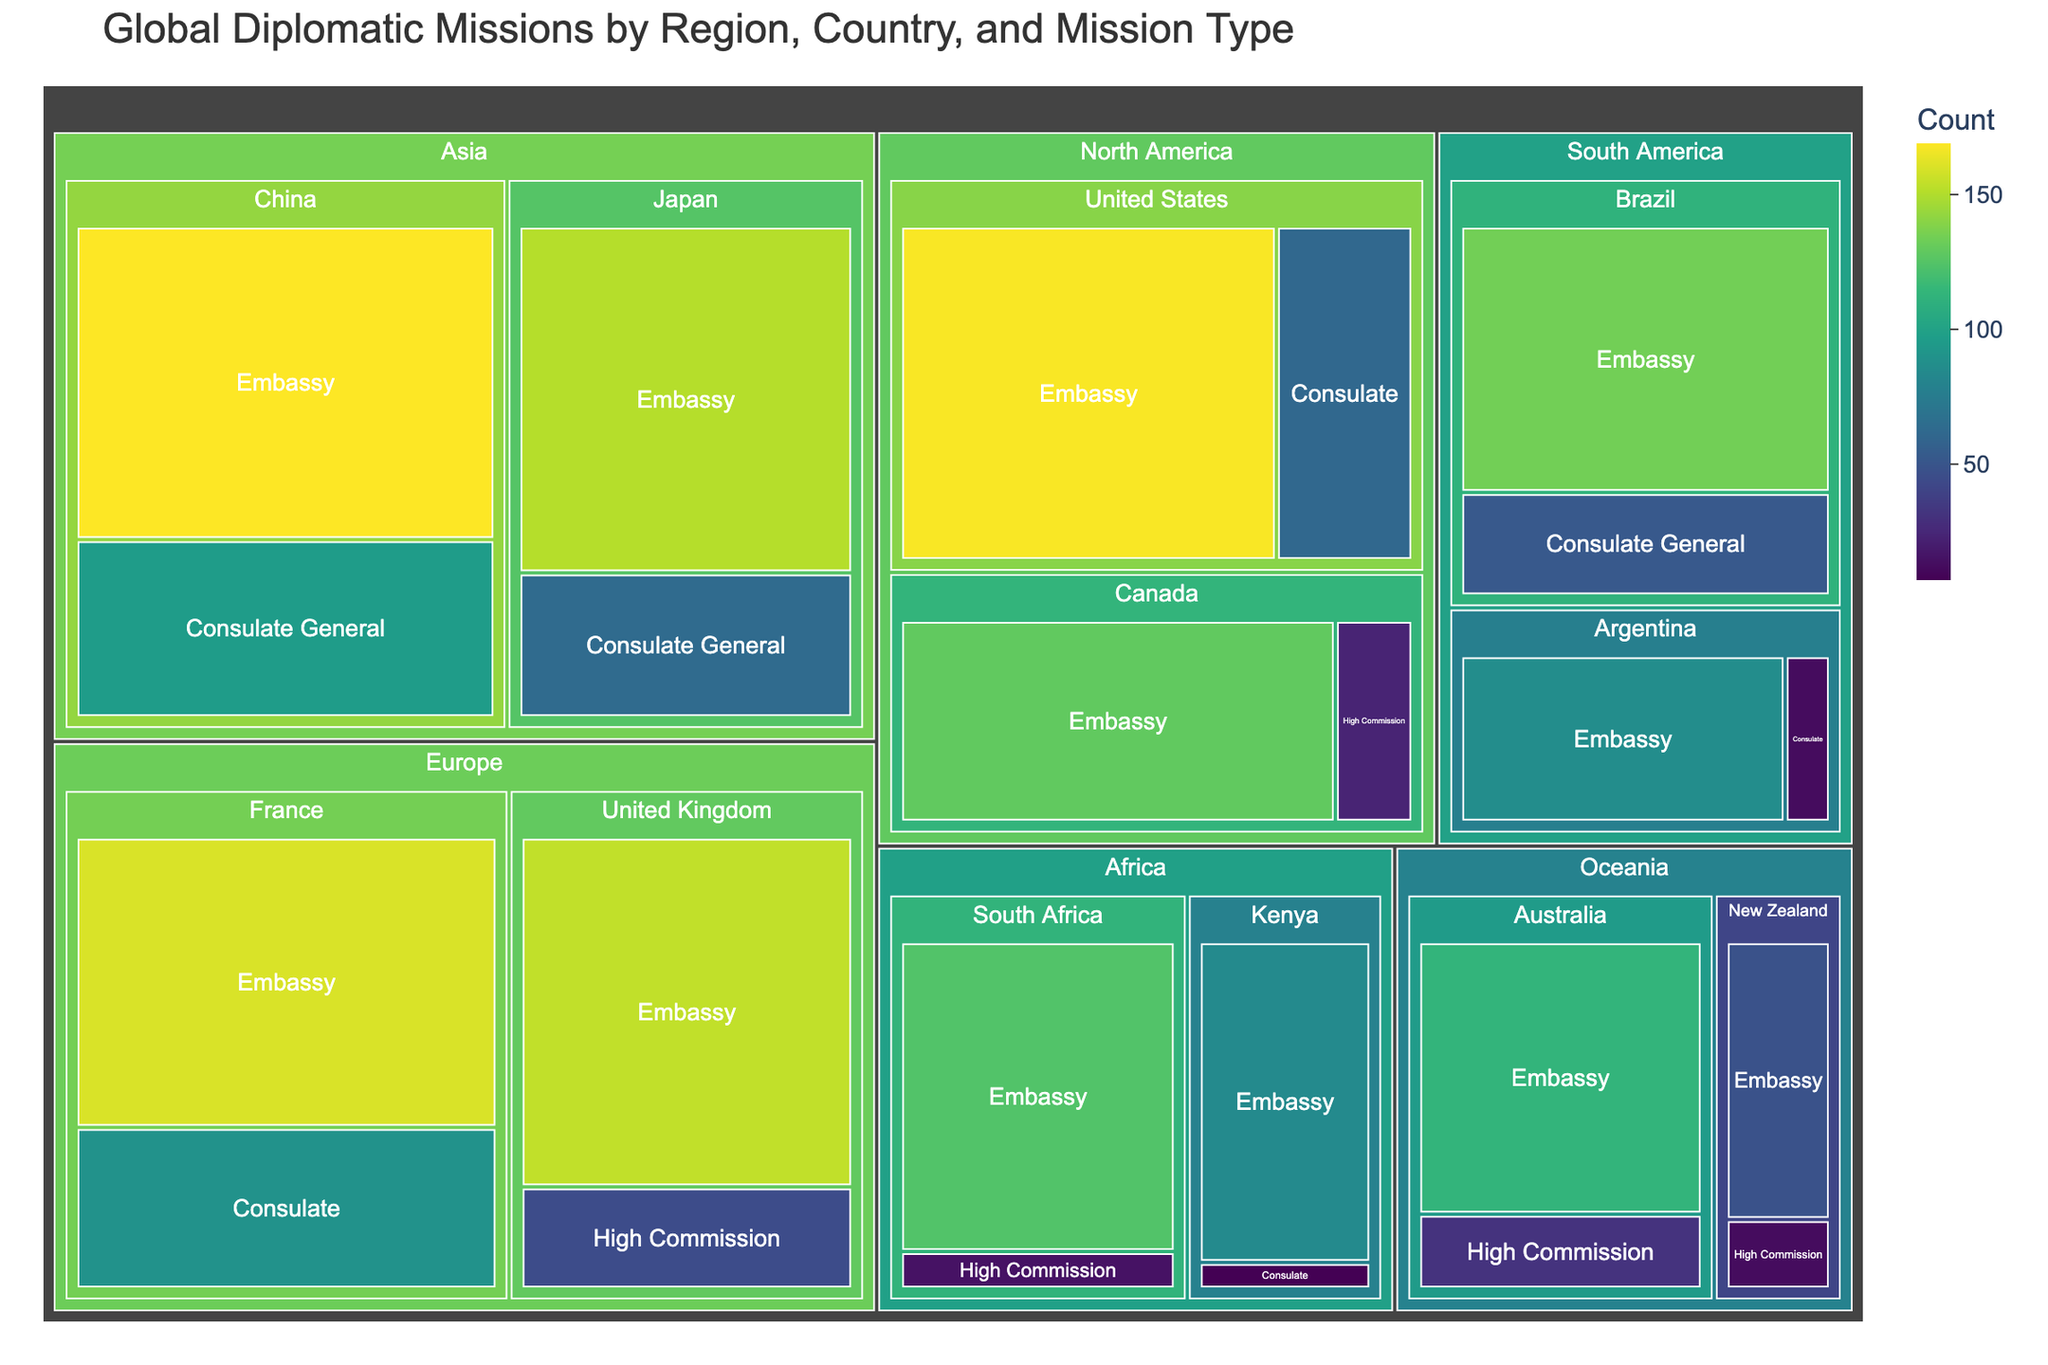What region has the highest number of diplomatic missions in total? To determine which region has the highest number of diplomatic missions in total, we need to sum up the counts for all countries within each region. North America has a total of 381 (United States: 168 + 61, Canada: 129 + 23). Europe has a total of 448 (United Kingdom: 154 + 45, France: 160 + 89). Asia has a total of 479 (China: 169 + 96, Japan: 151 + 63). Africa has a total of 230 (South Africa: 124 + 15, Kenya: 84 + 7). South America has a total of 284 (Brazil: 134 + 52, Argentina: 86 + 12). Oceania has a total of 204 (Australia: 113 + 31, New Zealand: 48 + 12). Therefore, Asia has the highest total number of diplomatic missions.
Answer: Asia Which country has the highest number of embassies? To find which country has the highest number of embassies, we look at the counts for embassies in each country. United States has 168, Canada has 129, United Kingdom has 154, France has 160, China has 169, Japan has 151, South Africa has 124, Kenya has 84, Brazil has 134, Argentina has 86, Australia has 113, and New Zealand has 48. Therefore, China has the highest number of embassies with 169.
Answer: China What is the total number of high commissions in the figure? To find the total number of high commissions, we need to sum up the counts for high commissions across all countries. The counts are: Canada: 23, United Kingdom: 45, South Africa: 15, Australia: 31, New Zealand: 12. Adding these together gives us 23 + 45 + 15 + 31 + 12 = 126.
Answer: 126 What percentage of diplomatic missions in France are consulates? First, we find the total number of diplomatic missions in France, which is 160 embassies + 89 consulates = 249. Then, we calculate the percentage of consulates: (89 / 249) * 100 ≈ 35.74%.
Answer: 35.74% Which country in South America has more consulates and by how much? To determine which country in South America has more consulates, we compare the counts. Brazil has 52 consulate generals and Argentina has 12 consulates. The difference is 52 - 12 = 40.
Answer: Brazil by 40 Compare the number of diplomatic missions between Japan and Australia. Which country has more and by how much? First, we sum up the total number of diplomatic missions for Japan and Australia. Japan has 151 embassies + 63 consulate generals = 214. Australia has 113 embassies + 31 high commissions = 144. The difference is 214 - 144 = 70.
Answer: Japan by 70 What is the ratio of consulates to embassies in the United States? The number of consulates in the United States is 61 and the number of embassies is 168. The ratio is 61:168 or simplified approximately 1:2.75.
Answer: 1:2.75 Which region has the least number of high commissions, and what is that number? We need to look at the counts of high commissions in each region. North America: 23, Europe: 45, Africa: 15, Oceania: 43. South America and Asia do not have any high commissions listed. The region with the least number of high commissions is Africa with 15.
Answer: Africa, 15 